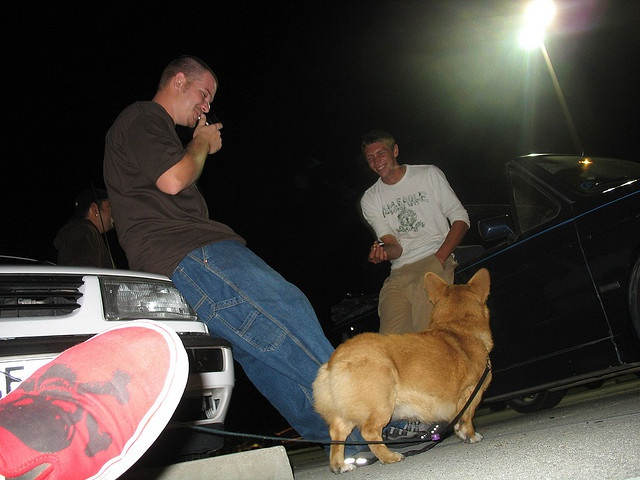Describe the objects in this image and their specific colors. I can see car in black, darkgreen, darkblue, and blue tones, people in black, blue, gray, and brown tones, people in black, lightpink, white, darkgray, and gray tones, car in black, white, gray, and darkgray tones, and dog in black, olive, tan, and maroon tones in this image. 